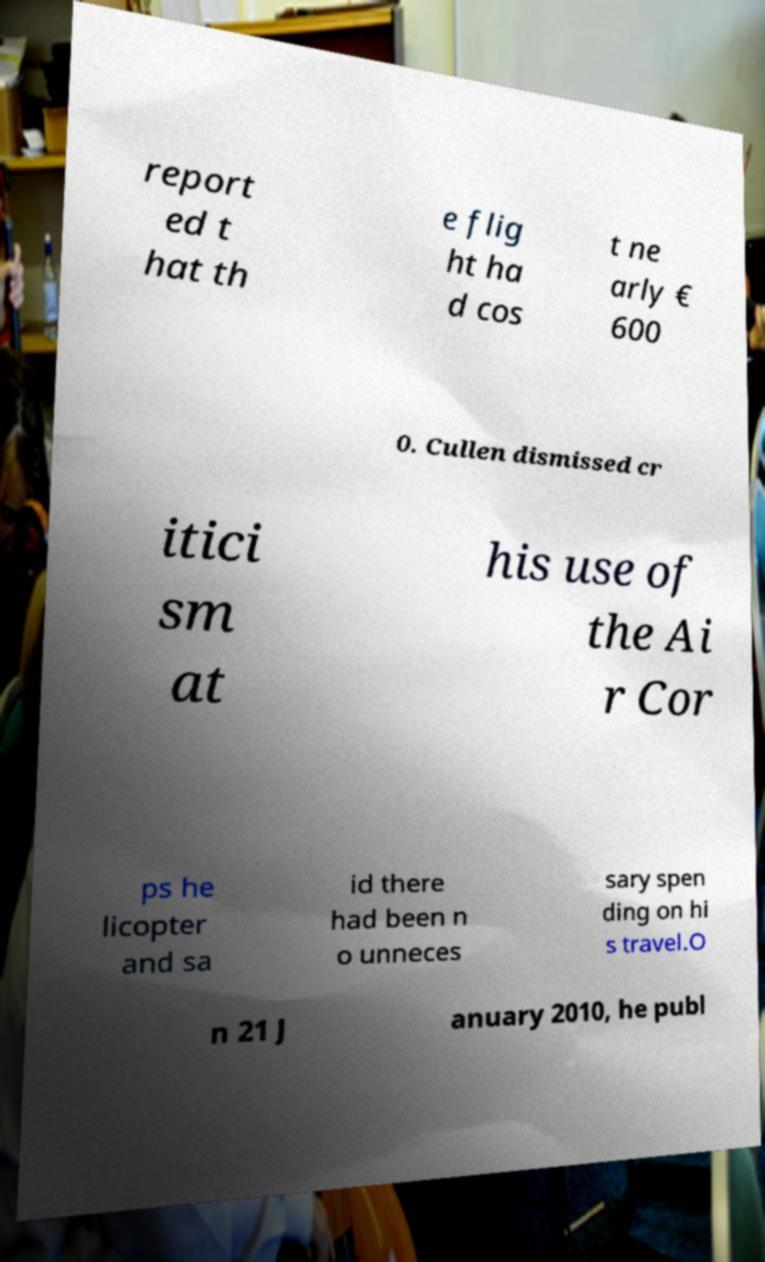Please read and relay the text visible in this image. What does it say? report ed t hat th e flig ht ha d cos t ne arly € 600 0. Cullen dismissed cr itici sm at his use of the Ai r Cor ps he licopter and sa id there had been n o unneces sary spen ding on hi s travel.O n 21 J anuary 2010, he publ 